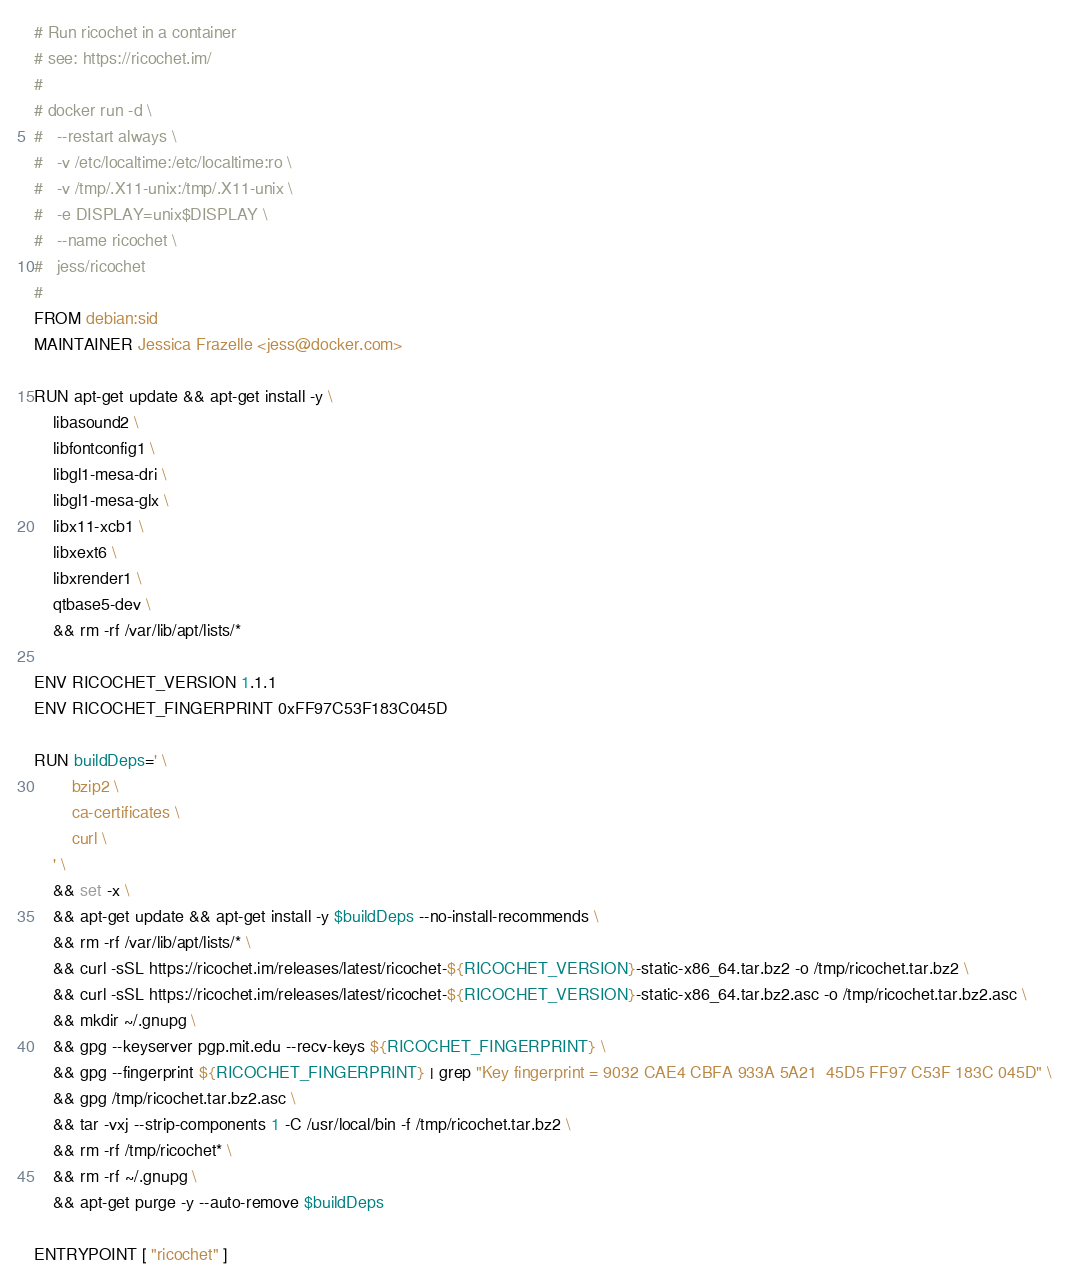Convert code to text. <code><loc_0><loc_0><loc_500><loc_500><_Dockerfile_># Run ricochet in a container
# see: https://ricochet.im/
#
# docker run -d \
#	--restart always \
#	-v /etc/localtime:/etc/localtime:ro \
#	-v /tmp/.X11-unix:/tmp/.X11-unix \
#	-e DISPLAY=unix$DISPLAY \
# 	--name ricochet \
# 	jess/ricochet
#
FROM debian:sid
MAINTAINER Jessica Frazelle <jess@docker.com>

RUN apt-get update && apt-get install -y \
	libasound2 \
	libfontconfig1 \
	libgl1-mesa-dri \
	libgl1-mesa-glx \
	libx11-xcb1 \
	libxext6 \
	libxrender1 \
	qtbase5-dev \
	&& rm -rf /var/lib/apt/lists/*

ENV RICOCHET_VERSION 1.1.1
ENV RICOCHET_FINGERPRINT 0xFF97C53F183C045D

RUN buildDeps=' \
		bzip2 \
		ca-certificates \
		curl \
	' \
	&& set -x \
	&& apt-get update && apt-get install -y $buildDeps --no-install-recommends \
	&& rm -rf /var/lib/apt/lists/* \
	&& curl -sSL https://ricochet.im/releases/latest/ricochet-${RICOCHET_VERSION}-static-x86_64.tar.bz2 -o /tmp/ricochet.tar.bz2 \
	&& curl -sSL https://ricochet.im/releases/latest/ricochet-${RICOCHET_VERSION}-static-x86_64.tar.bz2.asc -o /tmp/ricochet.tar.bz2.asc \
	&& mkdir ~/.gnupg \
	&& gpg --keyserver pgp.mit.edu --recv-keys ${RICOCHET_FINGERPRINT} \
	&& gpg --fingerprint ${RICOCHET_FINGERPRINT} | grep "Key fingerprint = 9032 CAE4 CBFA 933A 5A21  45D5 FF97 C53F 183C 045D" \
	&& gpg /tmp/ricochet.tar.bz2.asc \
	&& tar -vxj --strip-components 1 -C /usr/local/bin -f /tmp/ricochet.tar.bz2 \
	&& rm -rf /tmp/ricochet* \
	&& rm -rf ~/.gnupg \
	&& apt-get purge -y --auto-remove $buildDeps

ENTRYPOINT [ "ricochet" ]
</code> 